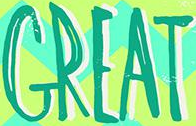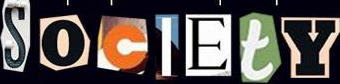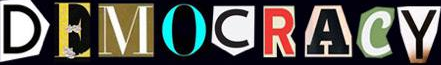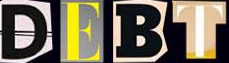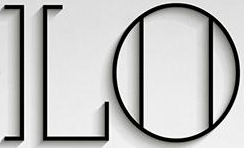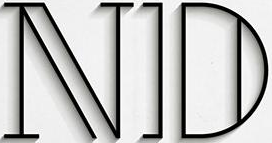Identify the words shown in these images in order, separated by a semicolon. GREAT; SocIEtY; DEMOCRACY; DEBT; LO; ND 